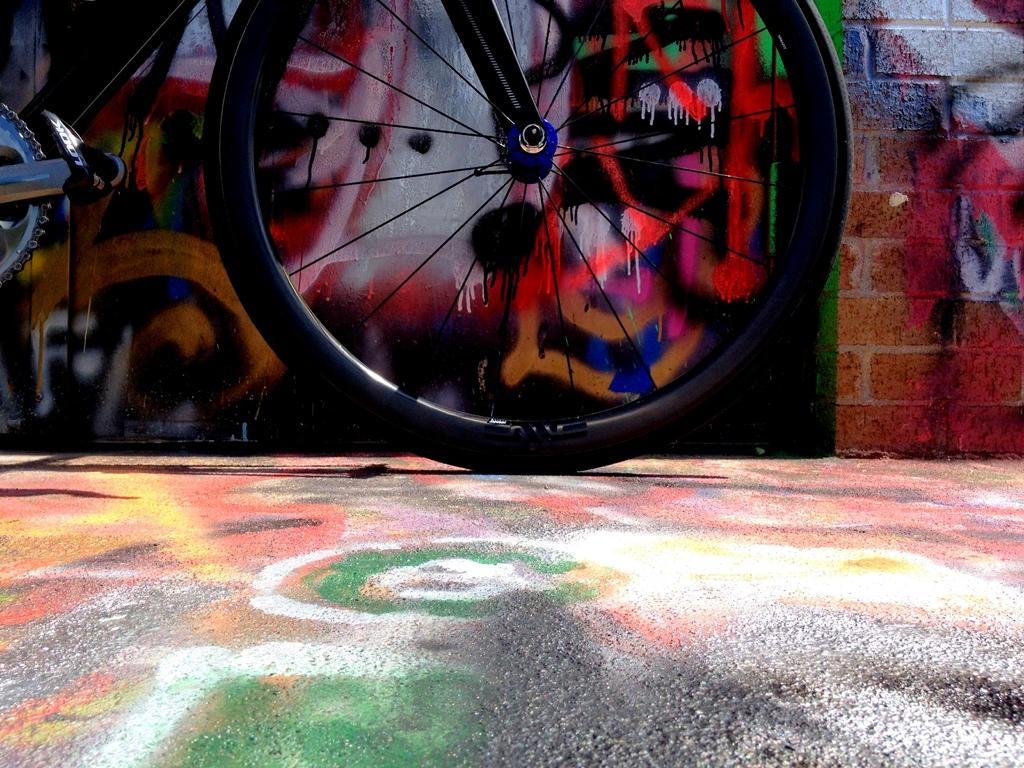What object is on the ground in the image? There is a wheel of a bicycle on the ground in the image. What can be seen on the wall in the background of the image? There is a painting on the wall in the background of the image. What type of knee injury is depicted in the painting on the wall? There is no knee injury depicted in the painting on the wall, as the facts provided do not mention any injuries or medical conditions. 